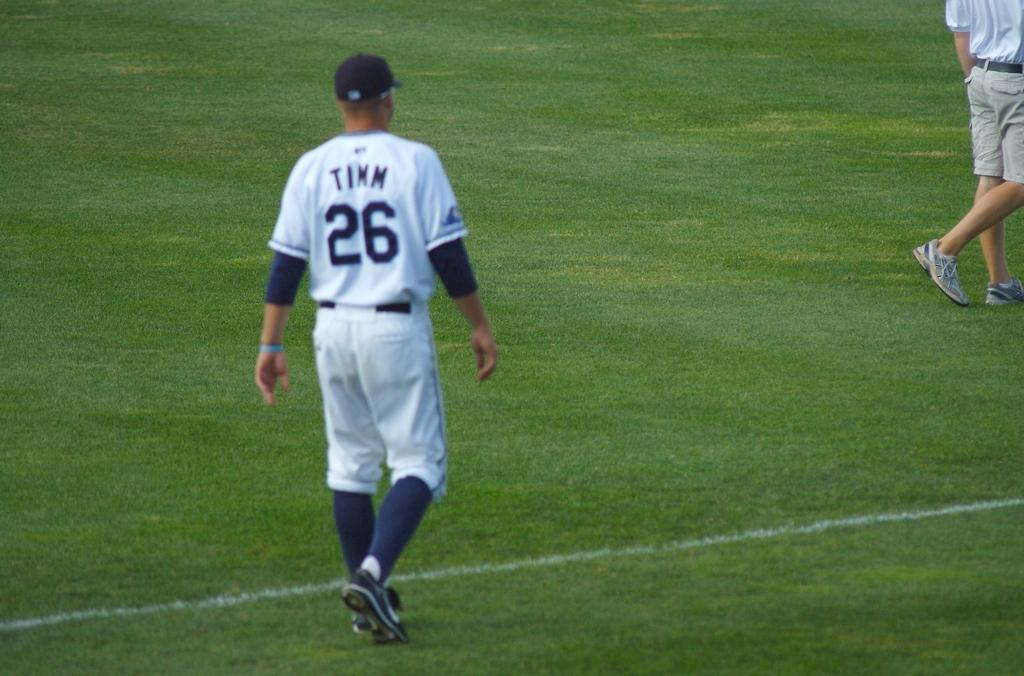Provide a one-sentence caption for the provided image. A baseball player named Timm who wears number 26 walks on the field. 